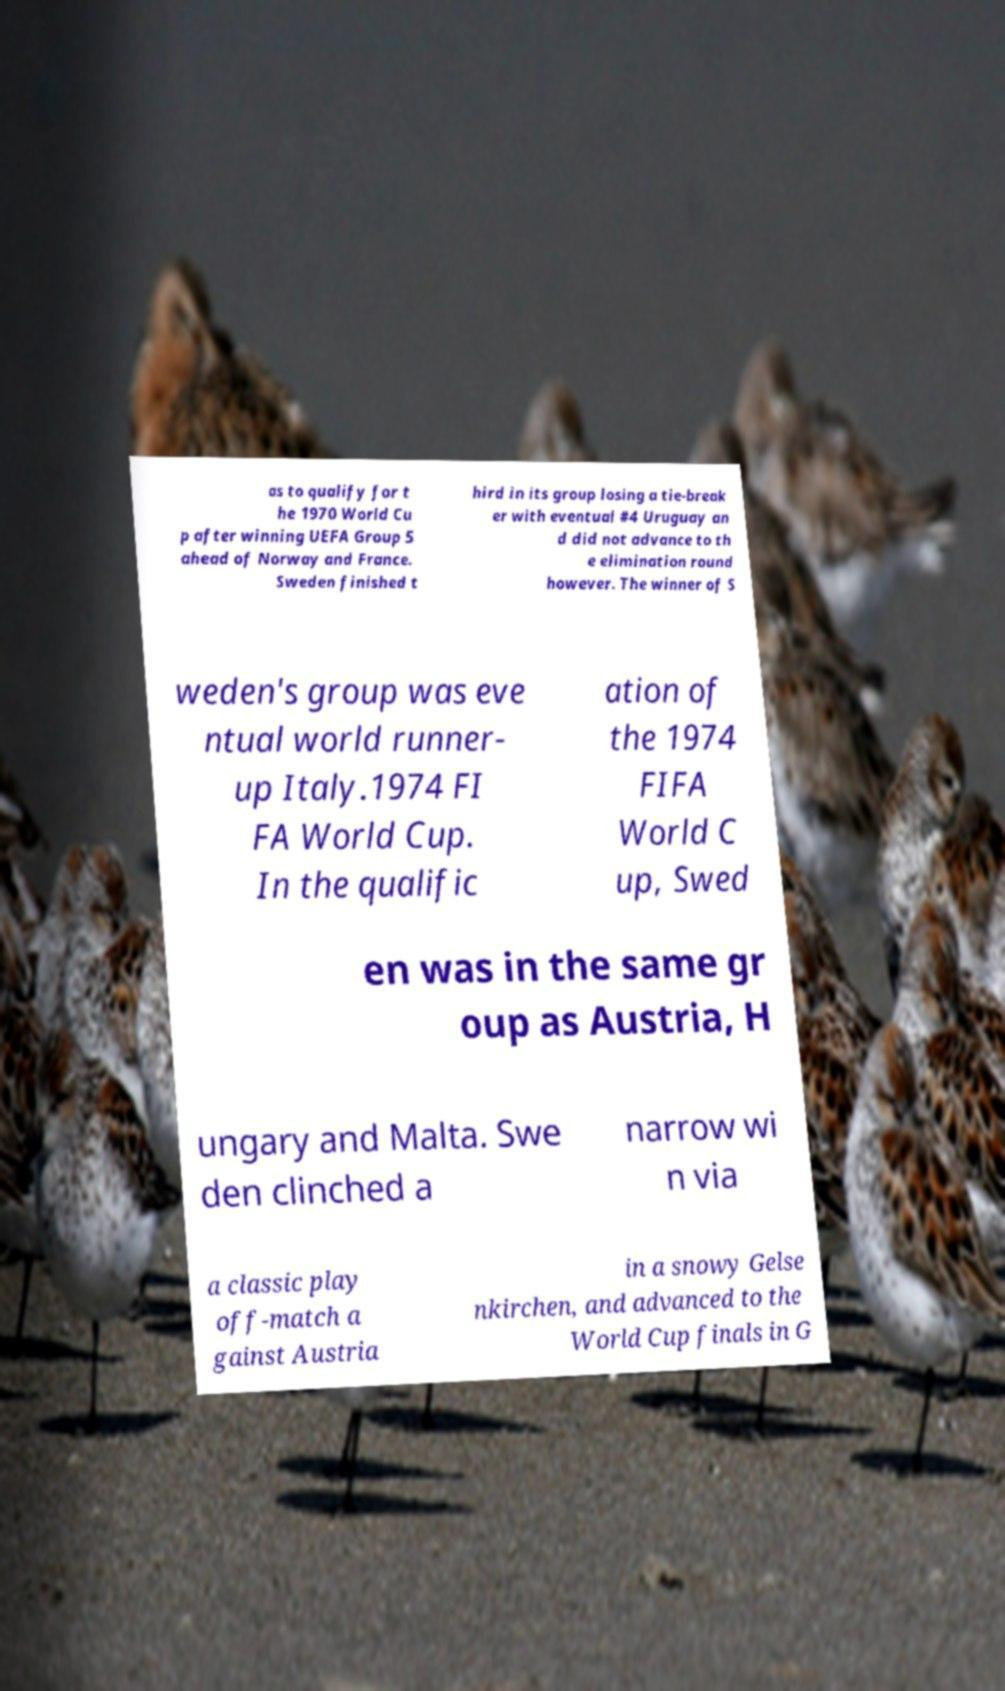Can you read and provide the text displayed in the image?This photo seems to have some interesting text. Can you extract and type it out for me? as to qualify for t he 1970 World Cu p after winning UEFA Group 5 ahead of Norway and France. Sweden finished t hird in its group losing a tie-break er with eventual #4 Uruguay an d did not advance to th e elimination round however. The winner of S weden's group was eve ntual world runner- up Italy.1974 FI FA World Cup. In the qualific ation of the 1974 FIFA World C up, Swed en was in the same gr oup as Austria, H ungary and Malta. Swe den clinched a narrow wi n via a classic play off-match a gainst Austria in a snowy Gelse nkirchen, and advanced to the World Cup finals in G 